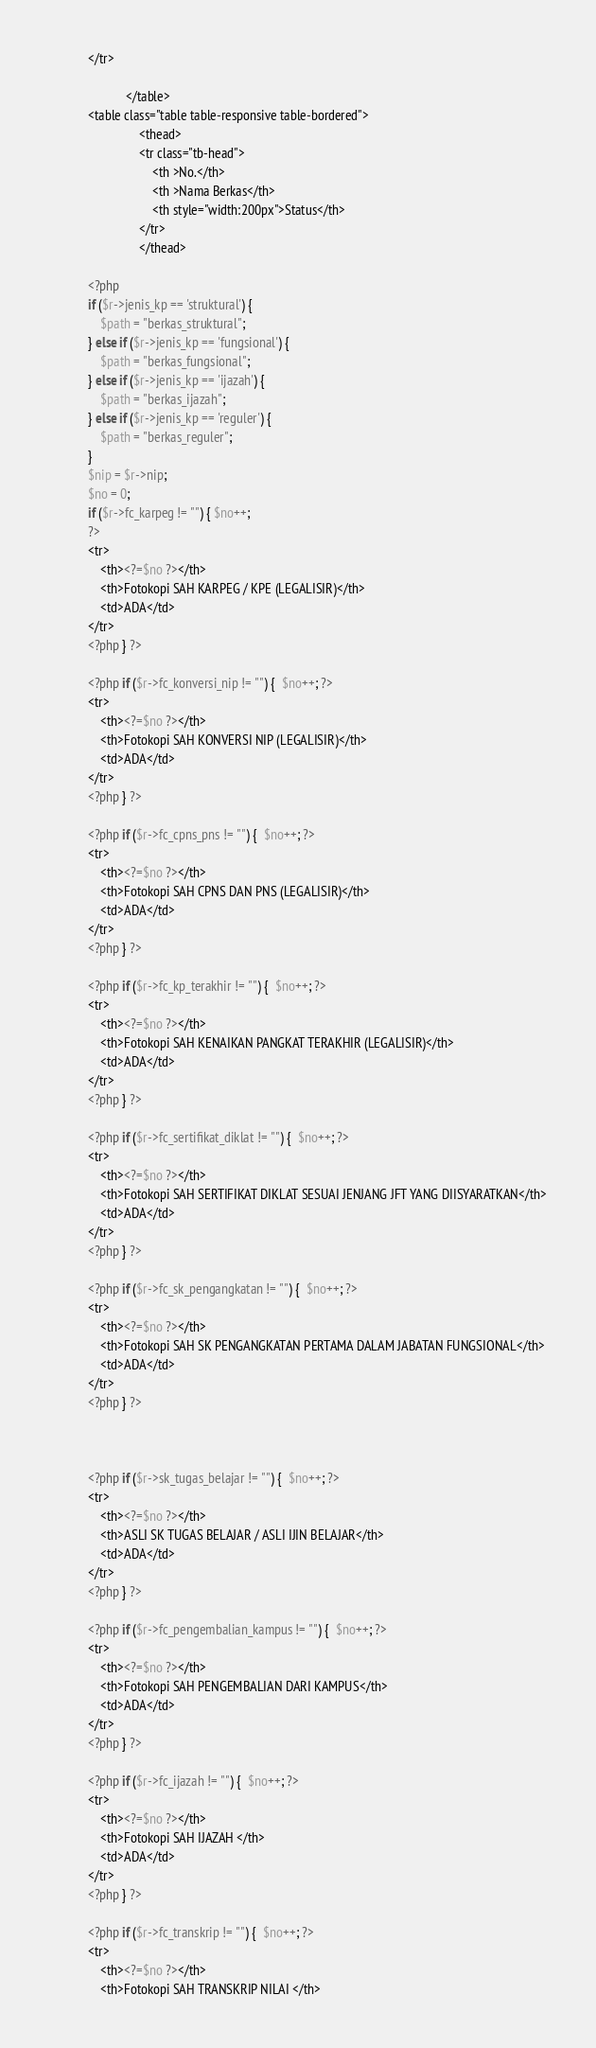<code> <loc_0><loc_0><loc_500><loc_500><_PHP_>			</tr>
			
						</table>
			<table class="table table-responsive table-bordered">
						    <thead>
						    <tr class="tb-head">
						        <th >No.</th>
						        <th >Nama Berkas</th>
						        <th style="width:200px">Status</th>
						    </tr>
						    </thead>
							
			<?php 
			if ($r->jenis_kp == 'struktural') {
				$path = "berkas_struktural";
			} else if ($r->jenis_kp == 'fungsional') { 
				$path = "berkas_fungsional";
			} else if ($r->jenis_kp == 'ijazah') { 
				$path = "berkas_ijazah";
			} else if ($r->jenis_kp == 'reguler') { 
				$path = "berkas_reguler";
			}	
			$nip = $r->nip;
			$no = 0;
			if ($r->fc_karpeg != "") { $no++;
			?> 
			<tr>
				<th><?=$no ?></th>
				<th>Fotokopi SAH KARPEG / KPE (LEGALISIR)</th>
				<td>ADA</td>
			</tr>	
			<?php } ?>
			
			<?php if ($r->fc_konversi_nip != "") {  $no++; ?> 
			<tr>
				<th><?=$no ?></th>
				<th>Fotokopi SAH KONVERSI NIP (LEGALISIR)</th>
				<td>ADA</td>
			</tr>	
			<?php } ?>
			
			<?php if ($r->fc_cpns_pns != "") {  $no++; ?> 
			<tr>
				<th><?=$no ?></th>
				<th>Fotokopi SAH CPNS DAN PNS (LEGALISIR)</th>
				<td>ADA</td>
			</tr>	
			<?php } ?>
			
			<?php if ($r->fc_kp_terakhir != "") {  $no++; ?> 
			<tr>
				<th><?=$no ?></th>
				<th>Fotokopi SAH KENAIKAN PANGKAT TERAKHIR (LEGALISIR)</th>
				<td>ADA</td>
			</tr>	
			<?php } ?>
			
			<?php if ($r->fc_sertifikat_diklat != "") {  $no++; ?> 
			<tr>
				<th><?=$no ?></th>
				<th>Fotokopi SAH SERTIFIKAT DIKLAT SESUAI JENJANG JFT YANG DIISYARATKAN</th>
				<td>ADA</td>
			</tr>	
			<?php } ?>
			
			<?php if ($r->fc_sk_pengangkatan != "") {  $no++; ?> 
			<tr>
				<th><?=$no ?></th>
				<th>Fotokopi SAH SK PENGANGKATAN PERTAMA DALAM JABATAN FUNGSIONAL</th>
				<td>ADA</td>
			</tr>	
			<?php } ?>
			
			
			
			<?php if ($r->sk_tugas_belajar != "") {  $no++; ?> 
			<tr>
				<th><?=$no ?></th>
				<th>ASLI SK TUGAS BELAJAR / ASLI IJIN BELAJAR</th>
				<td>ADA</td>
			</tr>	
			<?php } ?>
			
			<?php if ($r->fc_pengembalian_kampus != "") {  $no++; ?> 
			<tr>
				<th><?=$no ?></th>
				<th>Fotokopi SAH PENGEMBALIAN DARI KAMPUS</th>
				<td>ADA</td>
			</tr>	
			<?php } ?>
			
			<?php if ($r->fc_ijazah != "") {  $no++; ?> 
			<tr>
				<th><?=$no ?></th>
				<th>Fotokopi SAH IJAZAH </th>
				<td>ADA</td>
			</tr>	
			<?php } ?>
			
			<?php if ($r->fc_transkrip != "") {  $no++; ?> 
			<tr>
				<th><?=$no ?></th>
				<th>Fotokopi SAH TRANSKRIP NILAI </th></code> 